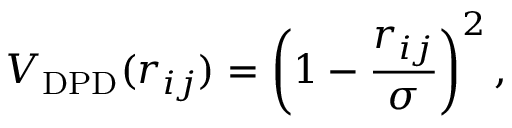<formula> <loc_0><loc_0><loc_500><loc_500>V _ { D P D } ( r _ { i j } ) = \left ( 1 - \frac { r _ { i j } } { \sigma } \right ) ^ { 2 } ,</formula> 